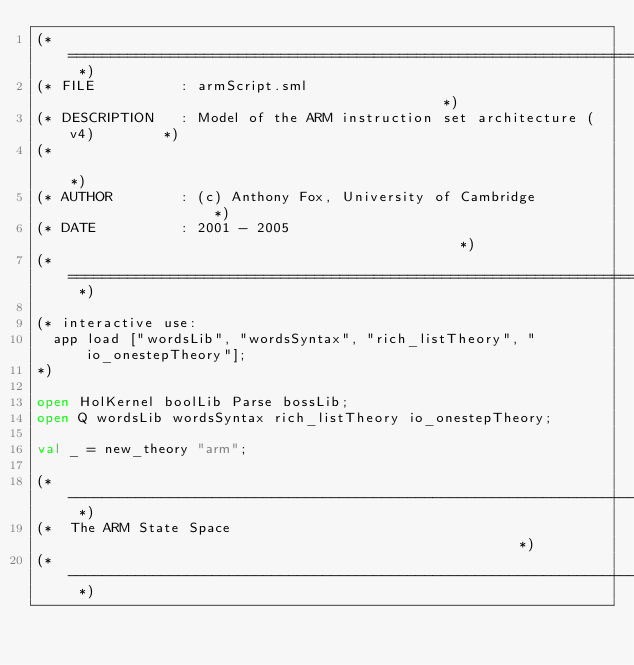<code> <loc_0><loc_0><loc_500><loc_500><_SML_>(* ========================================================================= *)
(* FILE          : armScript.sml                                             *)
(* DESCRIPTION   : Model of the ARM instruction set architecture (v4)        *)
(*                                                                           *)
(* AUTHOR        : (c) Anthony Fox, University of Cambridge                  *)
(* DATE          : 2001 - 2005                                               *)
(* ========================================================================= *)

(* interactive use:
  app load ["wordsLib", "wordsSyntax", "rich_listTheory", "io_onestepTheory"];
*)

open HolKernel boolLib Parse bossLib;
open Q wordsLib wordsSyntax rich_listTheory io_onestepTheory;

val _ = new_theory "arm";

(* ------------------------------------------------------------------------- *)
(*  The ARM State Space                                                      *)
(* ------------------------------------------------------------------------- *)
</code> 